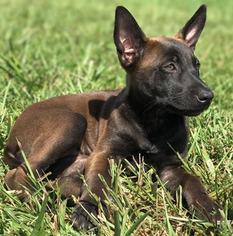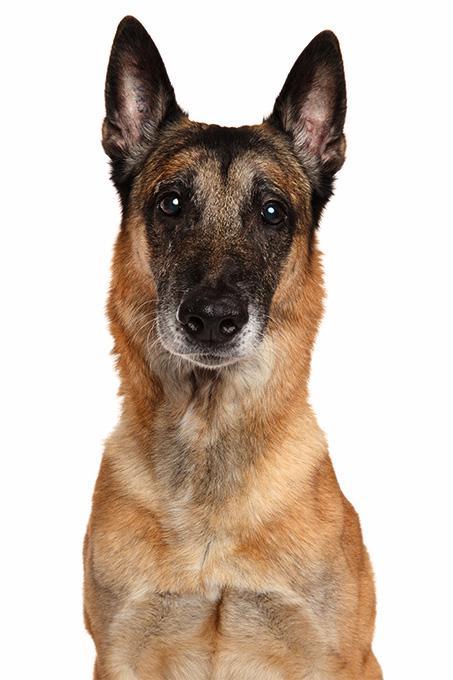The first image is the image on the left, the second image is the image on the right. Examine the images to the left and right. Is the description "In one of the images there is a dog sitting and wear a harness with a leash attached." accurate? Answer yes or no. No. The first image is the image on the left, the second image is the image on the right. Considering the images on both sides, is "An image shows a young dog wearing a black harness with a leash attached." valid? Answer yes or no. No. 